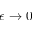<formula> <loc_0><loc_0><loc_500><loc_500>\epsilon \rightarrow 0</formula> 